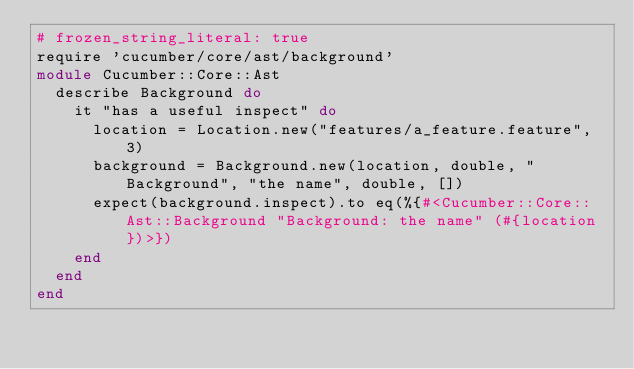<code> <loc_0><loc_0><loc_500><loc_500><_Ruby_># frozen_string_literal: true
require 'cucumber/core/ast/background'
module Cucumber::Core::Ast
  describe Background do
    it "has a useful inspect" do
      location = Location.new("features/a_feature.feature", 3)
      background = Background.new(location, double, "Background", "the name", double, [])
      expect(background.inspect).to eq(%{#<Cucumber::Core::Ast::Background "Background: the name" (#{location})>})
    end
  end
end
</code> 